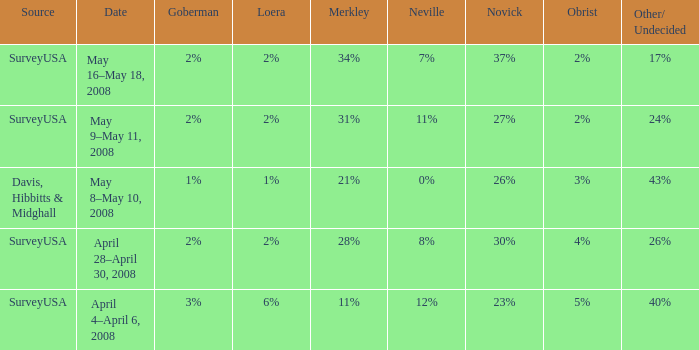On which date can we find a novick of 26%? May 8–May 10, 2008. 